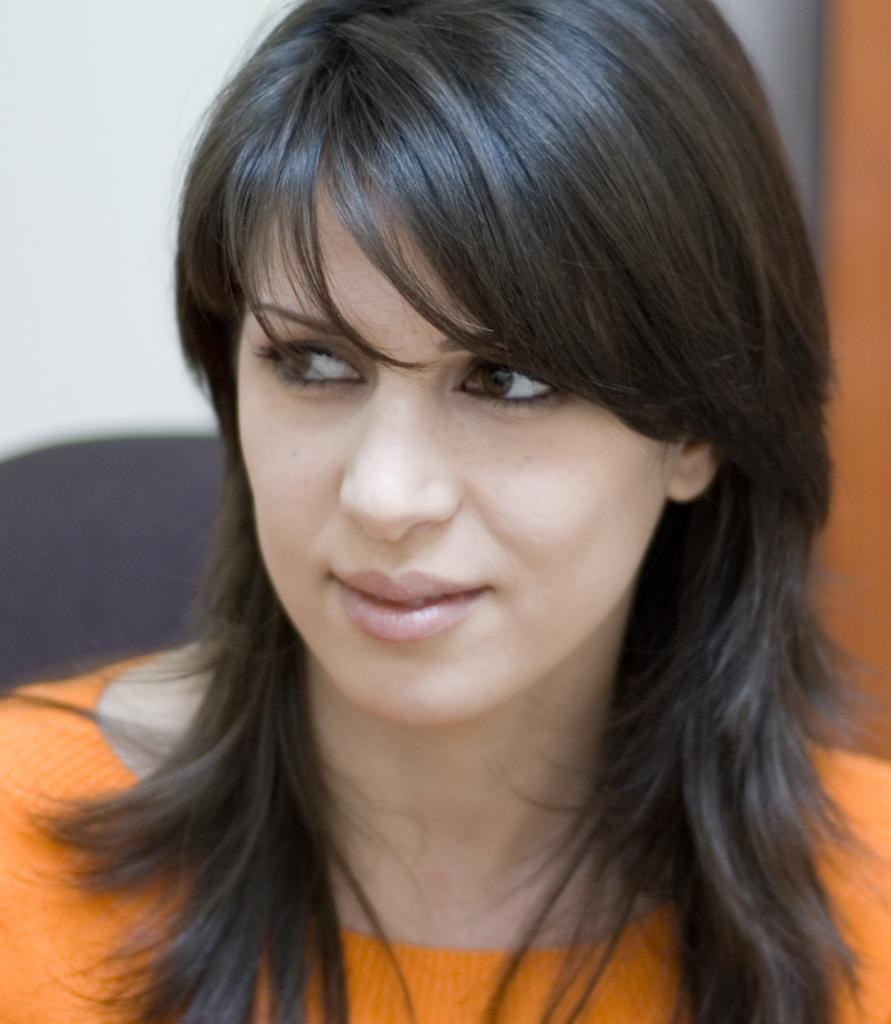Who is the main subject in the picture? There is a woman in the picture. What is the woman wearing? The woman is wearing an orange dress. Can you describe the background of the woman? The background of the woman is blurred. How many spiders can be seen crawling on the woman's dress in the image? There are no spiders visible on the woman's dress in the image. What type of comb is the woman using to style her hair in the image? There is no comb visible in the image, and the woman's hair is not shown. 